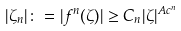<formula> <loc_0><loc_0><loc_500><loc_500>| \zeta _ { n } | \colon = | f ^ { n } ( \zeta ) | \geq C _ { n } | \zeta | ^ { A c ^ { n } }</formula> 